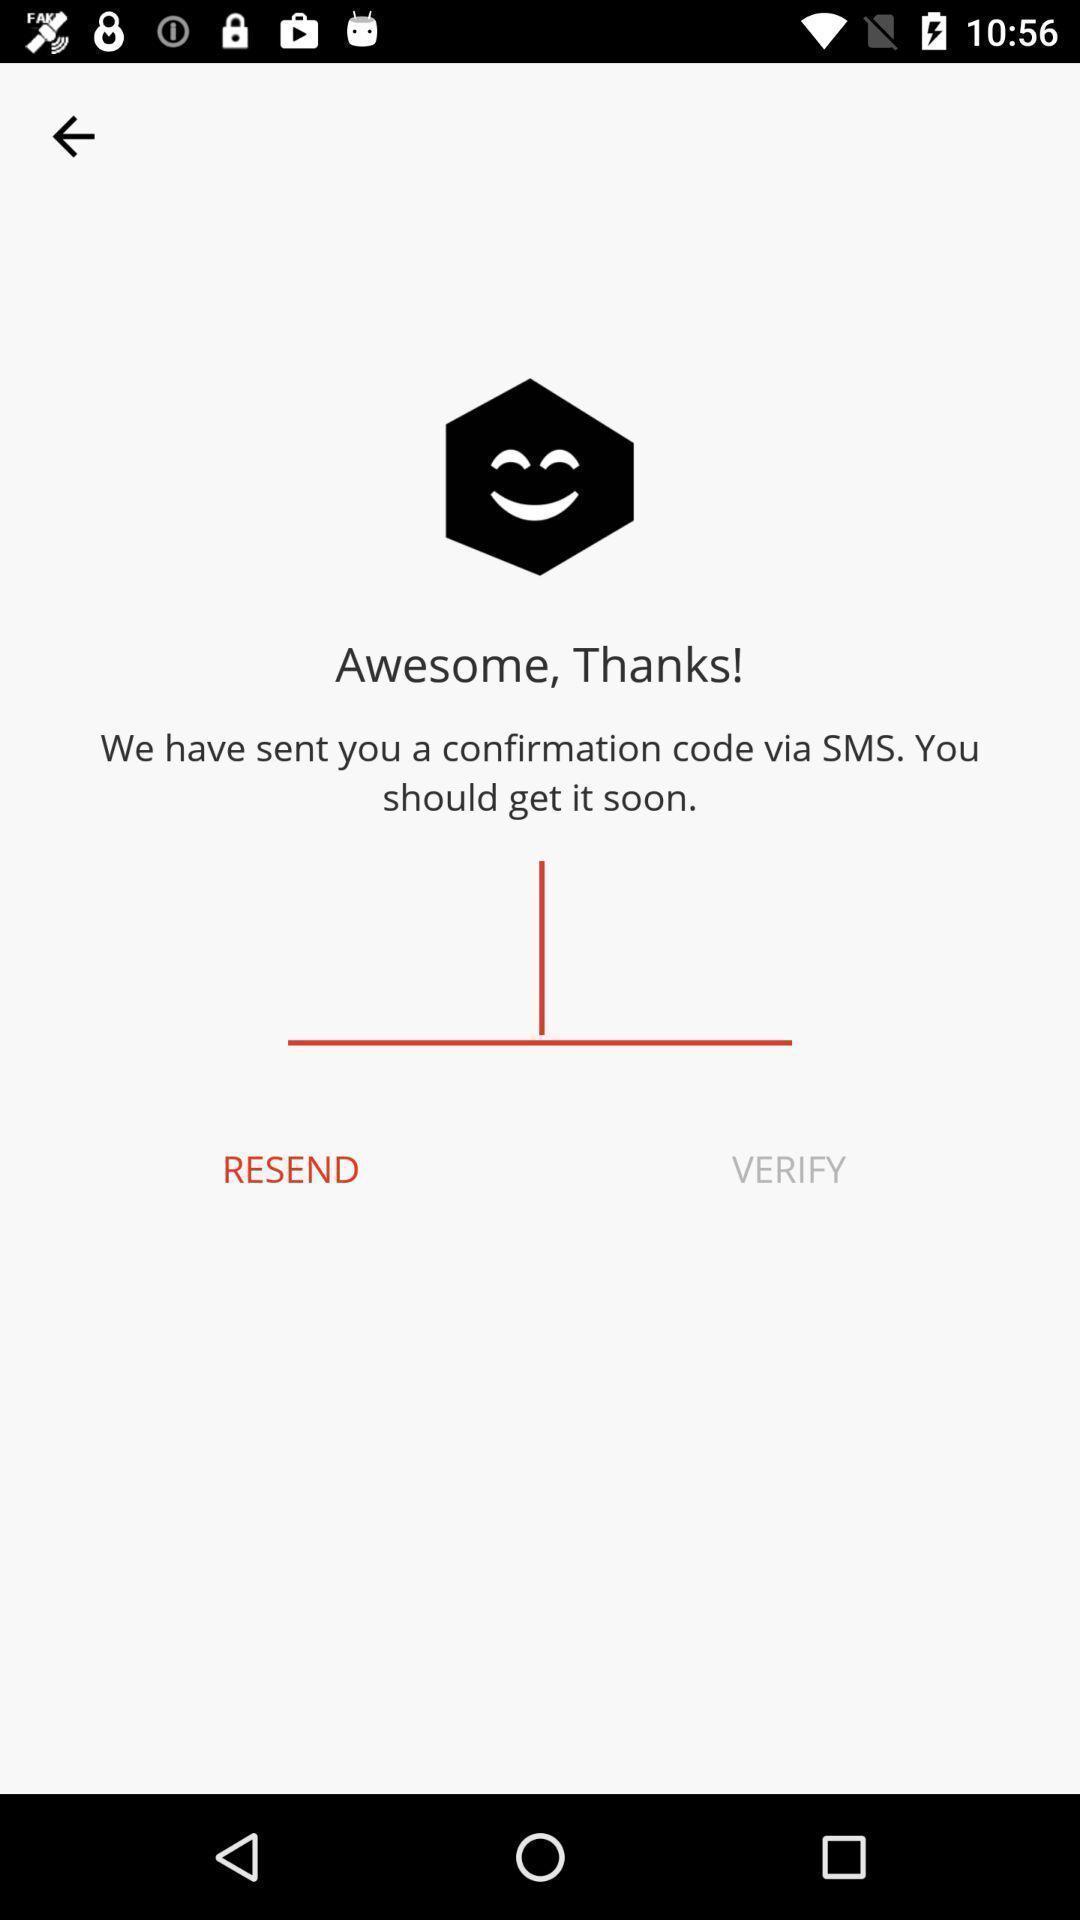Explain what's happening in this screen capture. Screen displaying the page asking to enter the code. 